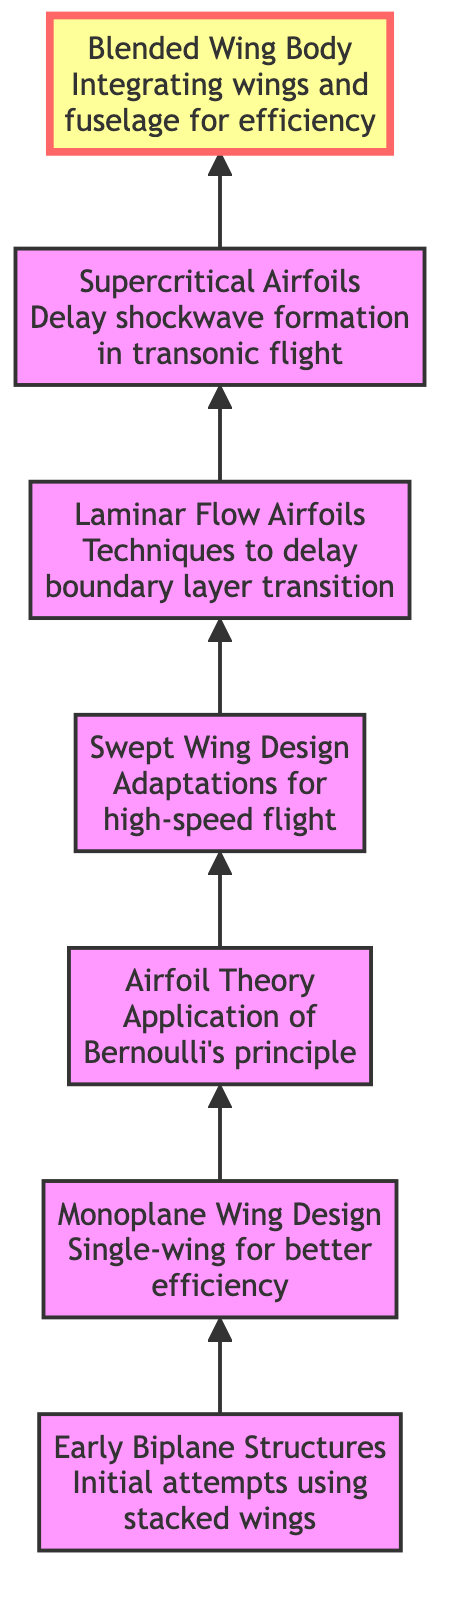What is the top node of the diagram? The top node of the diagram is labeled "Blended Wing Body and Advanced Configurations." This is determined by identifying the element at the highest position in the flow, which is the last item listed in the flow from bottom to top.
Answer: Blended Wing Body and Advanced Configurations How many nodes are in the diagram? The diagram includes seven nodes, which can be found by counting each unique element that represents a stage in the evolution of wing design theories, starting from Early Biplane Structures to Blended Wing Body and Advanced Configurations.
Answer: 7 What is the direct predecessor of "Supercritical Airfoils"? The node directly preceding "Supercritical Airfoils" is "Laminar Flow Airfoils." This relationship is indicated by the direct arrow connecting the two elements in the flowchart.
Answer: Laminar Flow Airfoils Which wing design introduced Bernoulli's principle in its theory? "Introduction of Airfoil Theory" is the node that applies Bernoulli's principle, as indicated by the description associated with that specific element in the diagram.
Answer: Introduction of Airfoil Theory What significant advancement is attributed to "Swept Wing Design"? The "Swept Wing Design" is attributed to adaptations for high-speed flight, as stated in its description. This involves reasoning through the description presented in the diagram to identify its notable feature.
Answer: High-speed flight Which node emphasizes techniques to delay boundary layer transition? The node that emphasizes techniques to delay boundary layer transition is "Laminar Flow Airfoils." This is found by reviewing the descriptions of the nodes up to that point and identifying the relevant technologies mentioned.
Answer: Laminar Flow Airfoils What innovative approach is highlighted at the highest level of wing design? The highest level of wing design highlights "Blended Wing Body and Advanced Configurations," as this is the title of the top node in the chart. This is determined by reviewing the flow from bottom to top.
Answer: Blended Wing Body and Advanced Configurations Which aircraft is an example of the Monoplane Wing Design? An example of the Monoplane Wing Design is the "Spirit of St. Louis," noted in the description connected to that specific node in the diagram.
Answer: Spirit of St. Louis What key technology is employed in "Supercritical Airfoils" to manage transonic flight? "Supercritical Airfoils" utilizes wing designs to delay shockwave formation to reduce wave drag in transonic flight, as explained in its description.
Answer: Delay shockwave formation 